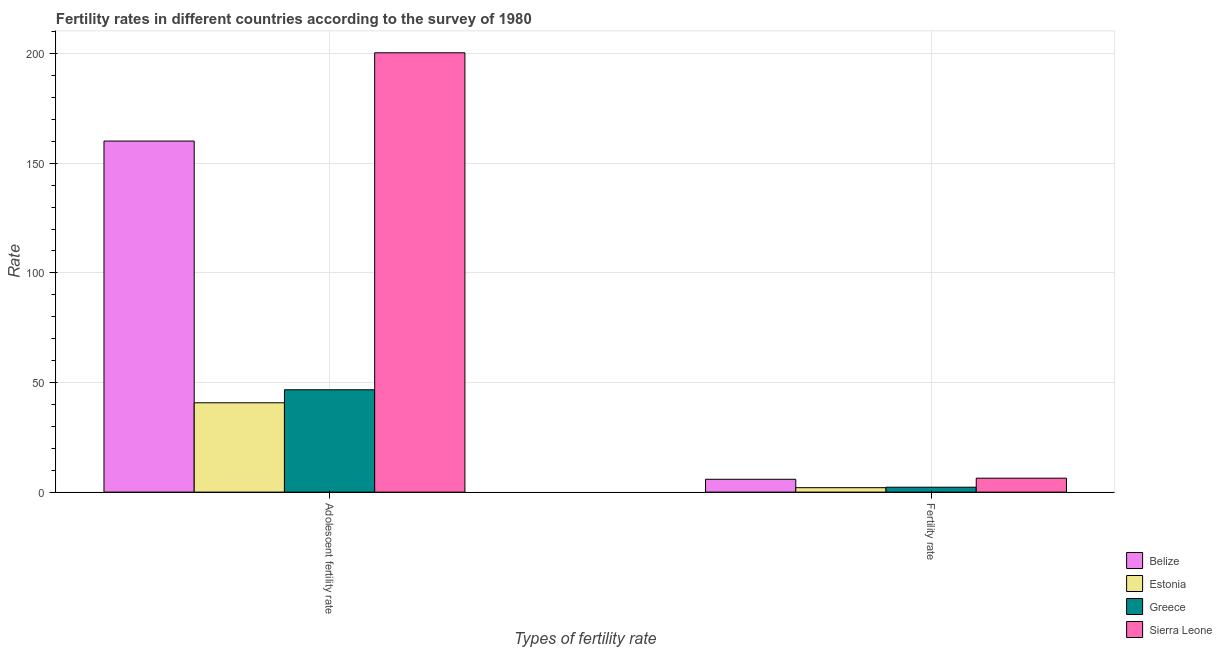How many different coloured bars are there?
Offer a very short reply. 4. Are the number of bars per tick equal to the number of legend labels?
Your response must be concise. Yes. Are the number of bars on each tick of the X-axis equal?
Give a very brief answer. Yes. How many bars are there on the 1st tick from the right?
Your response must be concise. 4. What is the label of the 1st group of bars from the left?
Provide a short and direct response. Adolescent fertility rate. What is the adolescent fertility rate in Estonia?
Offer a very short reply. 40.75. Across all countries, what is the maximum fertility rate?
Provide a succinct answer. 6.36. Across all countries, what is the minimum fertility rate?
Your answer should be compact. 2.02. In which country was the adolescent fertility rate maximum?
Give a very brief answer. Sierra Leone. In which country was the fertility rate minimum?
Keep it short and to the point. Estonia. What is the total fertility rate in the graph?
Ensure brevity in your answer.  16.45. What is the difference between the adolescent fertility rate in Belize and that in Sierra Leone?
Make the answer very short. -40.27. What is the difference between the adolescent fertility rate in Estonia and the fertility rate in Greece?
Your answer should be very brief. 38.52. What is the average adolescent fertility rate per country?
Make the answer very short. 112.01. What is the difference between the adolescent fertility rate and fertility rate in Sierra Leone?
Keep it short and to the point. 194.07. In how many countries, is the adolescent fertility rate greater than 50 ?
Offer a terse response. 2. What is the ratio of the adolescent fertility rate in Sierra Leone to that in Estonia?
Provide a short and direct response. 4.92. In how many countries, is the fertility rate greater than the average fertility rate taken over all countries?
Your answer should be compact. 2. What does the 1st bar from the left in Fertility rate represents?
Your response must be concise. Belize. What does the 4th bar from the right in Adolescent fertility rate represents?
Keep it short and to the point. Belize. Are all the bars in the graph horizontal?
Your response must be concise. No. How many countries are there in the graph?
Make the answer very short. 4. What is the difference between two consecutive major ticks on the Y-axis?
Your answer should be compact. 50. Does the graph contain grids?
Keep it short and to the point. Yes. Where does the legend appear in the graph?
Keep it short and to the point. Bottom right. How many legend labels are there?
Your answer should be compact. 4. What is the title of the graph?
Offer a very short reply. Fertility rates in different countries according to the survey of 1980. Does "Curacao" appear as one of the legend labels in the graph?
Your response must be concise. No. What is the label or title of the X-axis?
Your answer should be very brief. Types of fertility rate. What is the label or title of the Y-axis?
Your response must be concise. Rate. What is the Rate of Belize in Adolescent fertility rate?
Your answer should be very brief. 160.16. What is the Rate in Estonia in Adolescent fertility rate?
Make the answer very short. 40.75. What is the Rate in Greece in Adolescent fertility rate?
Provide a succinct answer. 46.68. What is the Rate in Sierra Leone in Adolescent fertility rate?
Make the answer very short. 200.43. What is the Rate of Belize in Fertility rate?
Provide a short and direct response. 5.85. What is the Rate in Estonia in Fertility rate?
Provide a short and direct response. 2.02. What is the Rate in Greece in Fertility rate?
Your answer should be very brief. 2.23. What is the Rate of Sierra Leone in Fertility rate?
Offer a very short reply. 6.36. Across all Types of fertility rate, what is the maximum Rate in Belize?
Provide a succinct answer. 160.16. Across all Types of fertility rate, what is the maximum Rate in Estonia?
Offer a terse response. 40.75. Across all Types of fertility rate, what is the maximum Rate in Greece?
Offer a terse response. 46.68. Across all Types of fertility rate, what is the maximum Rate of Sierra Leone?
Provide a succinct answer. 200.43. Across all Types of fertility rate, what is the minimum Rate of Belize?
Your answer should be very brief. 5.85. Across all Types of fertility rate, what is the minimum Rate in Estonia?
Provide a short and direct response. 2.02. Across all Types of fertility rate, what is the minimum Rate of Greece?
Your answer should be very brief. 2.23. Across all Types of fertility rate, what is the minimum Rate of Sierra Leone?
Offer a very short reply. 6.36. What is the total Rate in Belize in the graph?
Ensure brevity in your answer.  166.01. What is the total Rate in Estonia in the graph?
Offer a very short reply. 42.77. What is the total Rate of Greece in the graph?
Provide a succinct answer. 48.91. What is the total Rate in Sierra Leone in the graph?
Give a very brief answer. 206.78. What is the difference between the Rate in Belize in Adolescent fertility rate and that in Fertility rate?
Give a very brief answer. 154.31. What is the difference between the Rate of Estonia in Adolescent fertility rate and that in Fertility rate?
Give a very brief answer. 38.73. What is the difference between the Rate of Greece in Adolescent fertility rate and that in Fertility rate?
Make the answer very short. 44.45. What is the difference between the Rate of Sierra Leone in Adolescent fertility rate and that in Fertility rate?
Offer a very short reply. 194.07. What is the difference between the Rate of Belize in Adolescent fertility rate and the Rate of Estonia in Fertility rate?
Offer a very short reply. 158.14. What is the difference between the Rate of Belize in Adolescent fertility rate and the Rate of Greece in Fertility rate?
Make the answer very short. 157.93. What is the difference between the Rate in Belize in Adolescent fertility rate and the Rate in Sierra Leone in Fertility rate?
Your response must be concise. 153.8. What is the difference between the Rate of Estonia in Adolescent fertility rate and the Rate of Greece in Fertility rate?
Offer a very short reply. 38.52. What is the difference between the Rate of Estonia in Adolescent fertility rate and the Rate of Sierra Leone in Fertility rate?
Your response must be concise. 34.39. What is the difference between the Rate of Greece in Adolescent fertility rate and the Rate of Sierra Leone in Fertility rate?
Your response must be concise. 40.33. What is the average Rate in Belize per Types of fertility rate?
Your answer should be compact. 83. What is the average Rate of Estonia per Types of fertility rate?
Offer a very short reply. 21.39. What is the average Rate in Greece per Types of fertility rate?
Your answer should be very brief. 24.46. What is the average Rate of Sierra Leone per Types of fertility rate?
Make the answer very short. 103.39. What is the difference between the Rate of Belize and Rate of Estonia in Adolescent fertility rate?
Keep it short and to the point. 119.41. What is the difference between the Rate in Belize and Rate in Greece in Adolescent fertility rate?
Offer a terse response. 113.48. What is the difference between the Rate of Belize and Rate of Sierra Leone in Adolescent fertility rate?
Make the answer very short. -40.27. What is the difference between the Rate in Estonia and Rate in Greece in Adolescent fertility rate?
Your response must be concise. -5.93. What is the difference between the Rate in Estonia and Rate in Sierra Leone in Adolescent fertility rate?
Offer a terse response. -159.68. What is the difference between the Rate of Greece and Rate of Sierra Leone in Adolescent fertility rate?
Give a very brief answer. -153.74. What is the difference between the Rate of Belize and Rate of Estonia in Fertility rate?
Keep it short and to the point. 3.83. What is the difference between the Rate of Belize and Rate of Greece in Fertility rate?
Provide a succinct answer. 3.62. What is the difference between the Rate in Belize and Rate in Sierra Leone in Fertility rate?
Ensure brevity in your answer.  -0.51. What is the difference between the Rate of Estonia and Rate of Greece in Fertility rate?
Offer a terse response. -0.21. What is the difference between the Rate of Estonia and Rate of Sierra Leone in Fertility rate?
Make the answer very short. -4.34. What is the difference between the Rate in Greece and Rate in Sierra Leone in Fertility rate?
Make the answer very short. -4.13. What is the ratio of the Rate of Belize in Adolescent fertility rate to that in Fertility rate?
Offer a terse response. 27.38. What is the ratio of the Rate in Estonia in Adolescent fertility rate to that in Fertility rate?
Your answer should be very brief. 20.17. What is the ratio of the Rate of Greece in Adolescent fertility rate to that in Fertility rate?
Your answer should be very brief. 20.93. What is the ratio of the Rate in Sierra Leone in Adolescent fertility rate to that in Fertility rate?
Keep it short and to the point. 31.53. What is the difference between the highest and the second highest Rate in Belize?
Your answer should be compact. 154.31. What is the difference between the highest and the second highest Rate of Estonia?
Offer a very short reply. 38.73. What is the difference between the highest and the second highest Rate of Greece?
Provide a succinct answer. 44.45. What is the difference between the highest and the second highest Rate in Sierra Leone?
Make the answer very short. 194.07. What is the difference between the highest and the lowest Rate in Belize?
Provide a succinct answer. 154.31. What is the difference between the highest and the lowest Rate of Estonia?
Your answer should be compact. 38.73. What is the difference between the highest and the lowest Rate of Greece?
Give a very brief answer. 44.45. What is the difference between the highest and the lowest Rate of Sierra Leone?
Provide a succinct answer. 194.07. 